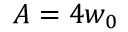<formula> <loc_0><loc_0><loc_500><loc_500>A = 4 w _ { 0 }</formula> 